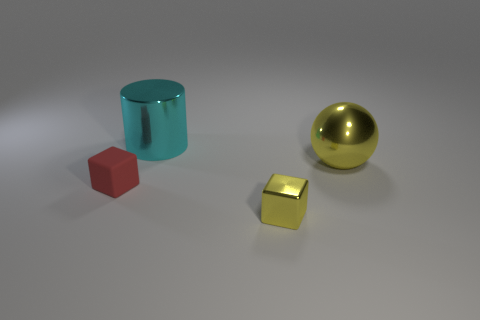Add 2 purple cylinders. How many objects exist? 6 Subtract all spheres. How many objects are left? 3 Add 3 yellow blocks. How many yellow blocks exist? 4 Subtract 0 cyan cubes. How many objects are left? 4 Subtract all big cyan metal things. Subtract all large spheres. How many objects are left? 2 Add 1 tiny rubber things. How many tiny rubber things are left? 2 